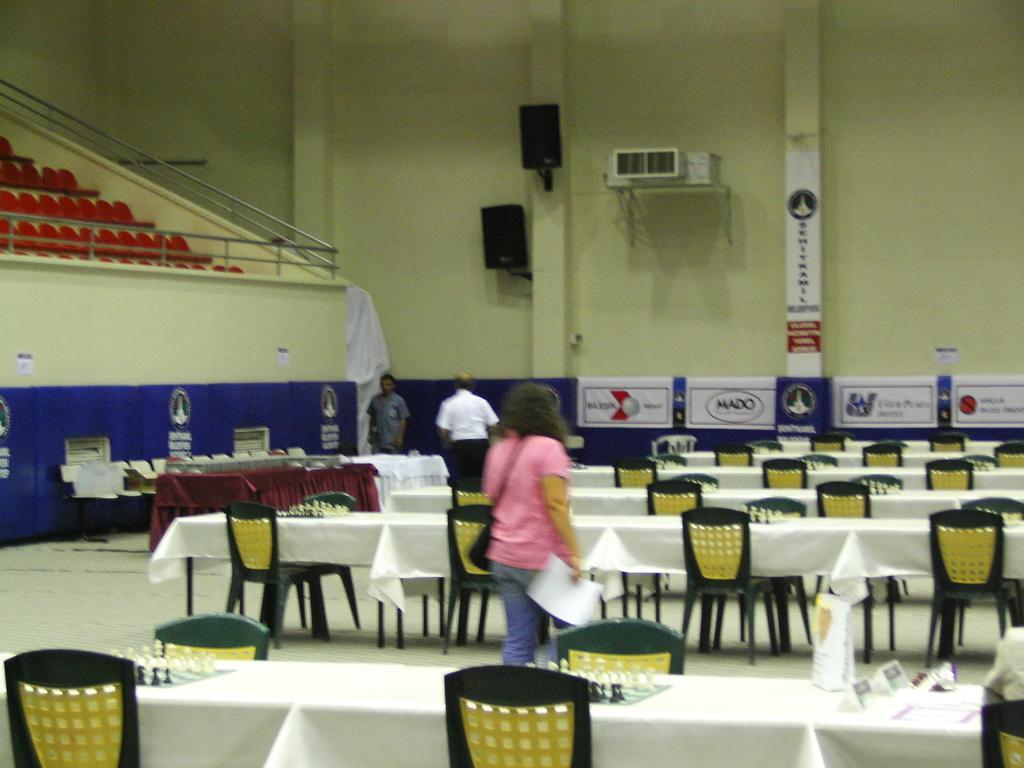Describe this image in one or two sentences. This image is clicked in an auditorium. There are many tables and chairs. On the table there are chess boards and name boards. There are three people walking. To the wall there are speakers, banners and air conditioner. To the left corner there are seats. 